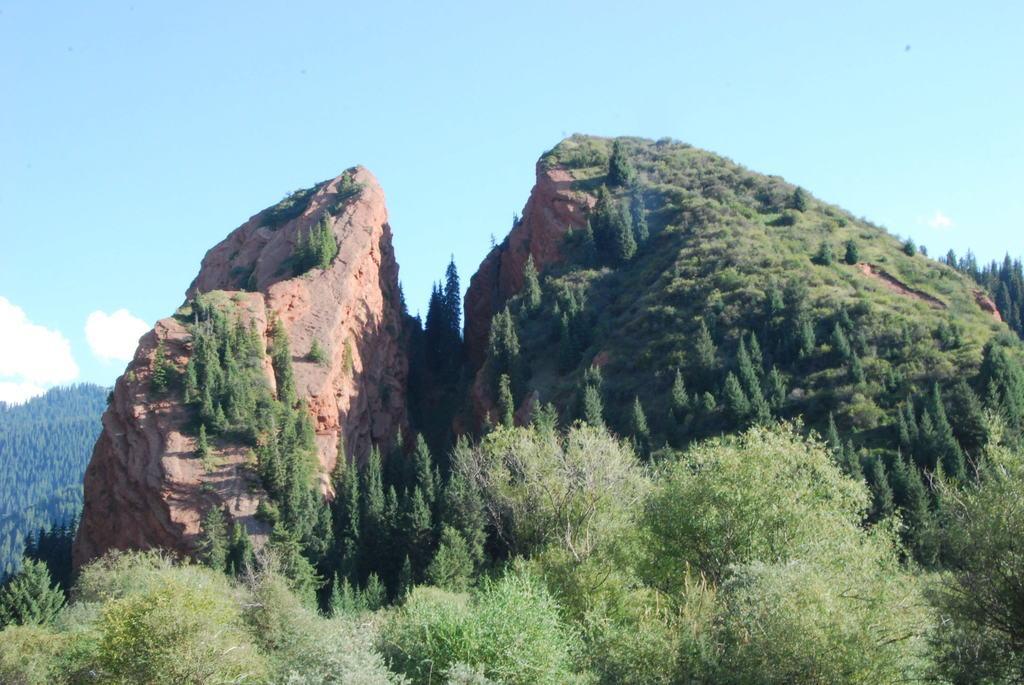Could you give a brief overview of what you see in this image? There is a hill and it is partially covered with greenery and in front of the hill there is thick grass and plants and in the background there is a sky. 